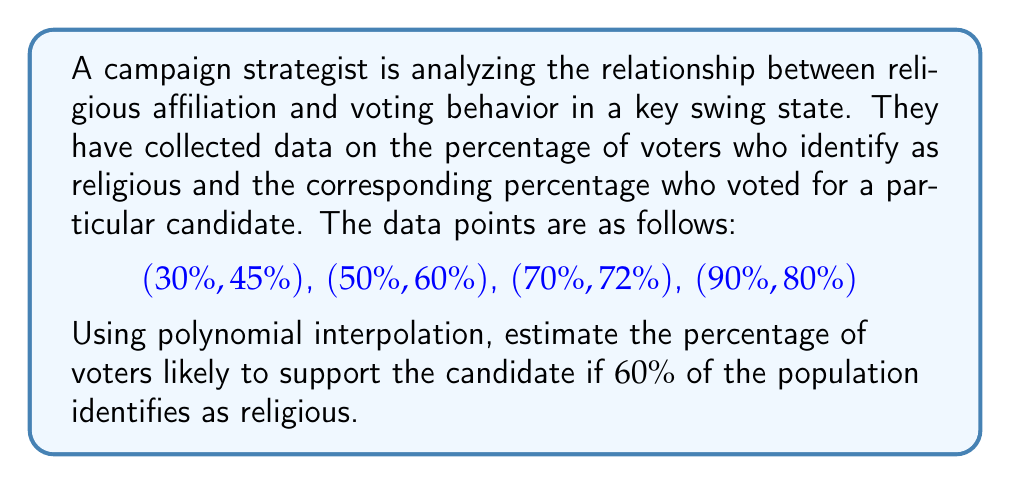Solve this math problem. To solve this problem, we'll use Lagrange polynomial interpolation.

Step 1: Define the Lagrange basis polynomials.
For each data point $(x_i, y_i)$, we define:

$$L_i(x) = \prod_{j \neq i} \frac{x - x_j}{x_i - x_j}$$

Step 2: Calculate each Lagrange basis polynomial for x = 60.

$$L_1(60) = \frac{(60-50)(60-70)(60-90)}{(30-50)(30-70)(30-90)} = -0.0694$$
$$L_2(60) = \frac{(60-30)(60-70)(60-90)}{(50-30)(50-70)(50-90)} = 0.5$$
$$L_3(60) = \frac{(60-30)(60-50)(60-90)}{(70-30)(70-50)(70-90)} = 0.6667$$
$$L_4(60) = \frac{(60-30)(60-50)(60-70)}{(90-30)(90-50)(90-70)} = -0.0972$$

Step 3: Construct the interpolating polynomial.

$$P(x) = \sum_{i=1}^n y_i L_i(x)$$

Step 4: Calculate the estimated percentage for x = 60.

$$P(60) = 45 \cdot (-0.0694) + 60 \cdot 0.5 + 72 \cdot 0.6667 + 80 \cdot (-0.0972)$$
$$P(60) = -3.123 + 30 + 48 - 7.776 = 67.101$$

Therefore, the estimated percentage of voters likely to support the candidate if 60% of the population identifies as religious is approximately 67.1%.
Answer: 67.1% 